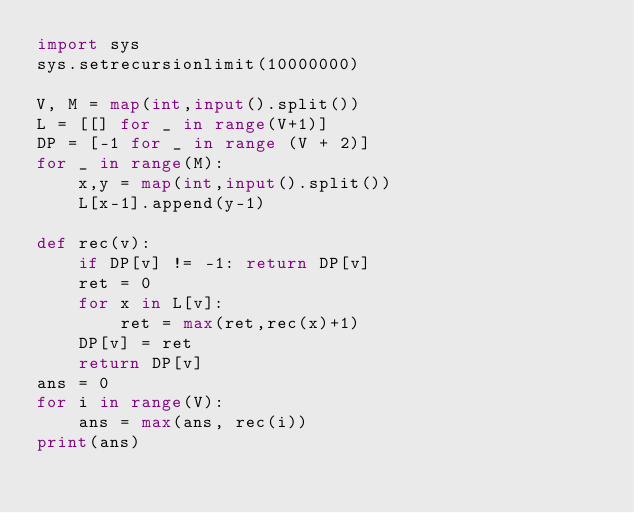<code> <loc_0><loc_0><loc_500><loc_500><_Python_>import sys
sys.setrecursionlimit(10000000)

V, M = map(int,input().split())
L = [[] for _ in range(V+1)]
DP = [-1 for _ in range (V + 2)]
for _ in range(M):
    x,y = map(int,input().split())
    L[x-1].append(y-1)

def rec(v):
    if DP[v] != -1: return DP[v]
    ret = 0
    for x in L[v]:
        ret = max(ret,rec(x)+1)
    DP[v] = ret
    return DP[v]
ans = 0
for i in range(V):
    ans = max(ans, rec(i))
print(ans)
</code> 